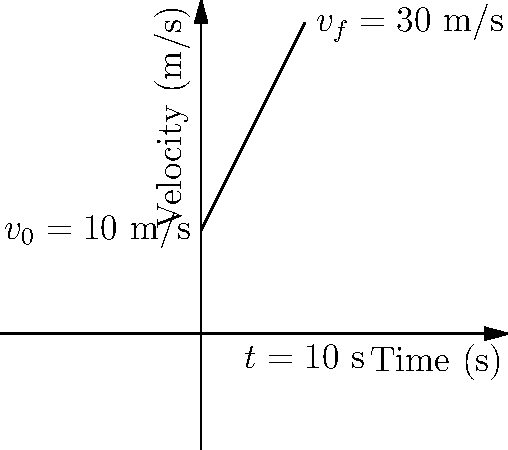You're preparing your 1957 Chevrolet Bel Air for a classic car rally. Starting from rest, you accelerate the car on a straight road. After 10 seconds, you reach a velocity of 30 m/s. Assuming constant acceleration, what was the acceleration of your classic Chevy during this time? Let's approach this step-by-step using the equations of motion:

1) We know the initial velocity $v_0 = 0$ m/s (starting from rest)
2) The final velocity $v_f = 30$ m/s
3) The time taken $t = 10$ s
4) We need to find the acceleration $a$

We can use the equation:
$v_f = v_0 + at$

Rearranging this equation to solve for $a$:
$a = \frac{v_f - v_0}{t}$

Substituting our known values:
$a = \frac{30 \text{ m/s} - 0 \text{ m/s}}{10 \text{ s}}$

$a = \frac{30 \text{ m/s}}{10 \text{ s}}$

$a = 3 \text{ m/s}^2$

Therefore, the acceleration of your classic Chevrolet Bel Air was 3 m/s².
Answer: 3 m/s² 